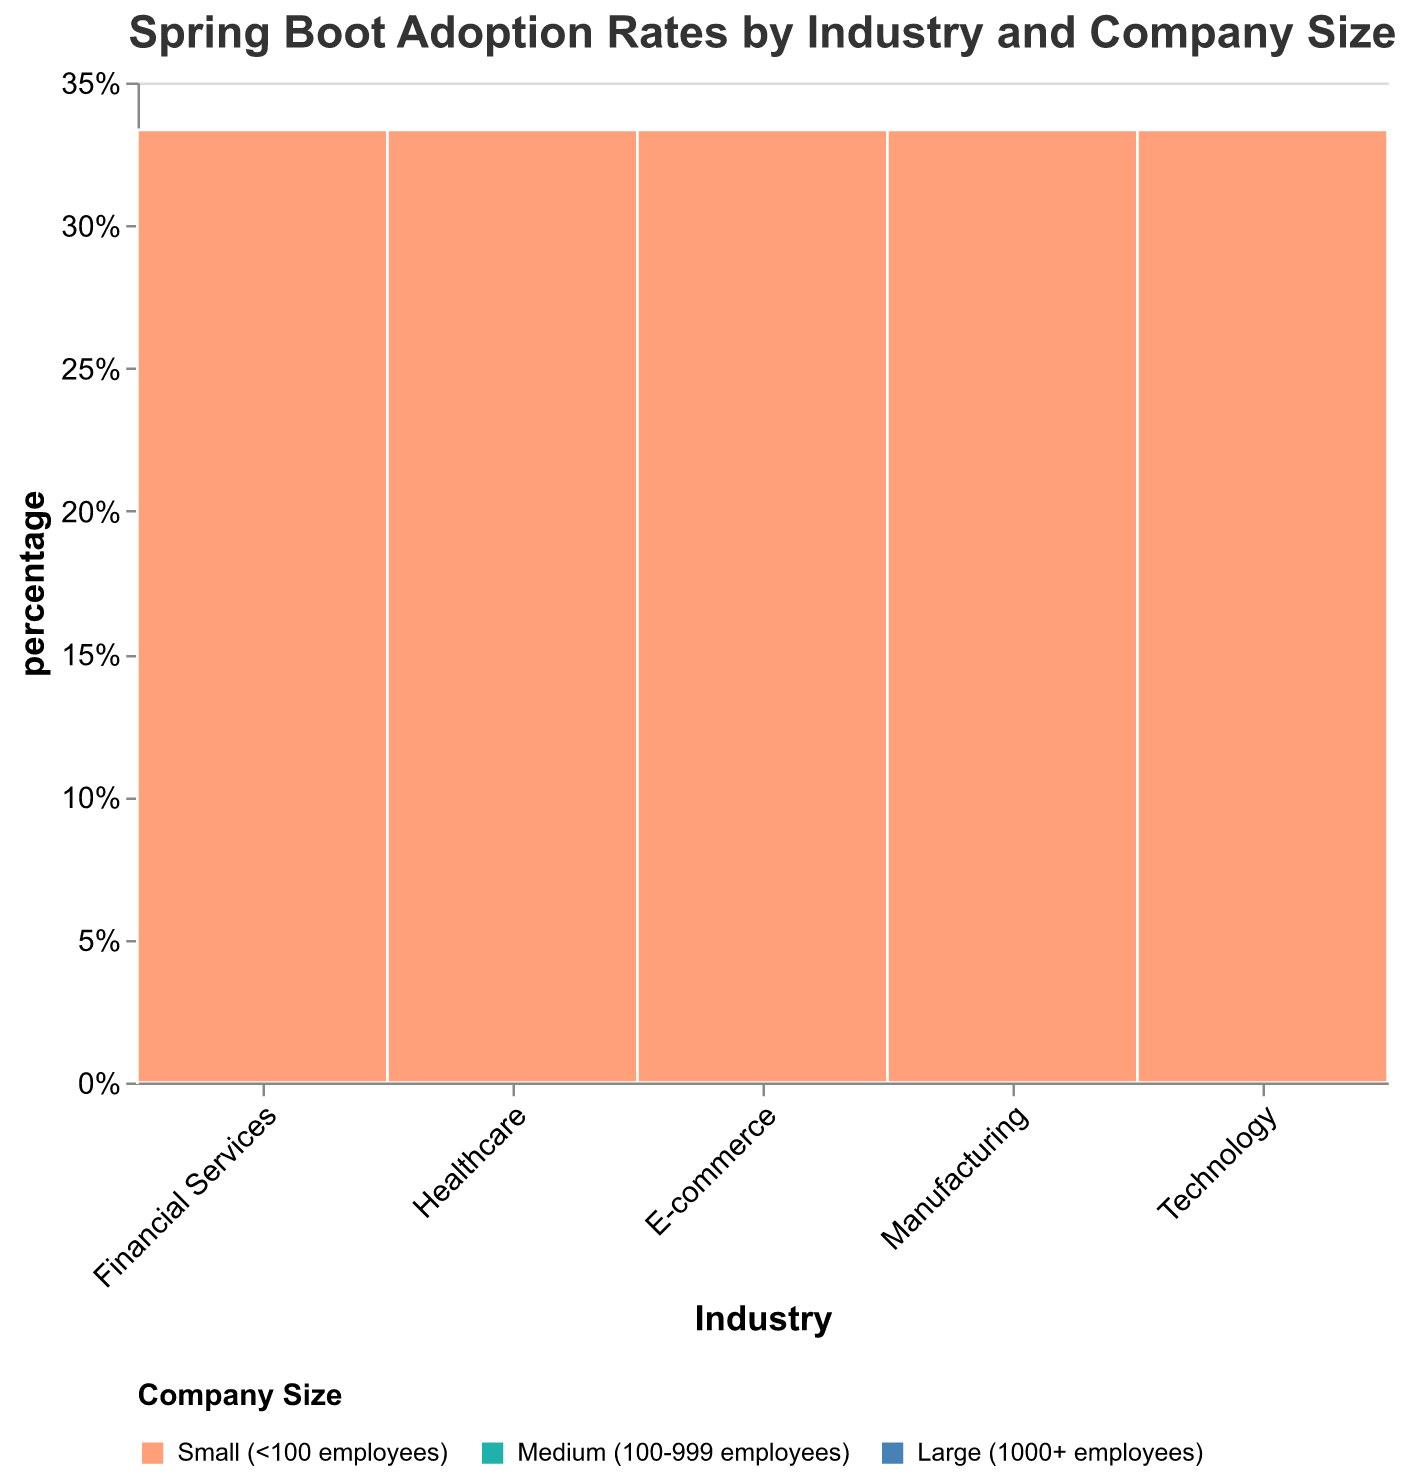What is the title of the figure? The title is usually prominent and located at the top of the figure. It provides context and summarizes what the figure displays. In this case, it reads "Spring Boot Adoption Rates by Industry and Company Size."
Answer: Spring Boot Adoption Rates by Industry and Company Size Which industry shows the highest adoption rate in large companies? To answer this, look at the section representing large companies within each industry and identify which one has the greatest height. The Technology industry has the tallest rectangle in the "Large" category.
Answer: Technology How does the adoption rate in small companies compare between E-commerce and Healthcare? Look at the sections representing small companies in both E-commerce and Healthcare. The percentage shown in E-commerce is significantly higher than in Healthcare.
Answer: E-commerce has a higher adoption rate than Healthcare What is the adoption rate of Spring Boot in medium-sized Healthcare companies? Hover over the Healthcare segment for medium-sized companies to see the tooltip, which displays the adoption rate value. It reads 65%.
Answer: 65% Among large companies, which industry has the lowest adoption rate? Review the heights of the "Large" rectangles across all industries and find the shortest one. Manufacturing has the shortest rectangle in the "Large" category.
Answer: Manufacturing Compare the overall width of the sections for Financial Services and Technology. What can you infer? Financial Services and Technology segments' widths can be compared to assess their relative adoption spread. A wider segment indicates a higher overall adoption rate across company sizes.
Answer: Technology has a wider section than Financial Services Explain the difference in adoption rates between large and small companies within the Manufacturing industry. Identify the heights of the "Large" and "Small" rectangles within the Manufacturing industry. The difference indicates how much higher the adoption rate is in large compared to small companies. The heights show 70% vs. 45%, giving a difference of 25%.
Answer: 25% What industry appears to have the most uniform adoption rates across different company sizes? Examine each industry's segment for variations in rectangle heights. The Technology industry has relatively even heights across different company sizes, indicating uniform adoption rates.
Answer: Technology Which industry has the largest adoption rate disparity between its largest and medium-sized companies? Calculate the difference in heights between the "Large" and "Medium" segments for each industry. The E-commerce industry has the largest disparity, with a height difference of 92% - 88% = 4%.
Answer: E-commerce 